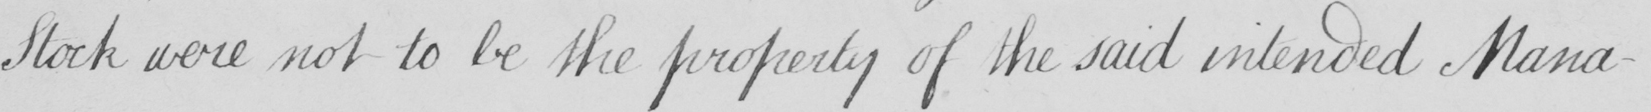Please transcribe the handwritten text in this image. Stock were not to be the property of the said intended Mana- 